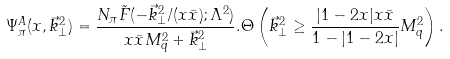Convert formula to latex. <formula><loc_0><loc_0><loc_500><loc_500>\Psi _ { \pi } ^ { A } ( x , \vec { k } _ { \bot } ^ { 2 } ) = \frac { N _ { \pi } \tilde { F } ( - \vec { k } _ { \bot } ^ { 2 } / ( x \bar { x } ) ; \Lambda ^ { 2 } ) } { x \bar { x } M _ { q } ^ { 2 } + \vec { k } _ { \bot } ^ { 2 } } . \Theta \left ( \vec { k } _ { \bot } ^ { 2 } \geq \frac { | 1 - 2 x | x \bar { x } } { 1 - | 1 - 2 x | } M _ { q } ^ { 2 } \right ) .</formula> 